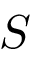Convert formula to latex. <formula><loc_0><loc_0><loc_500><loc_500>S</formula> 